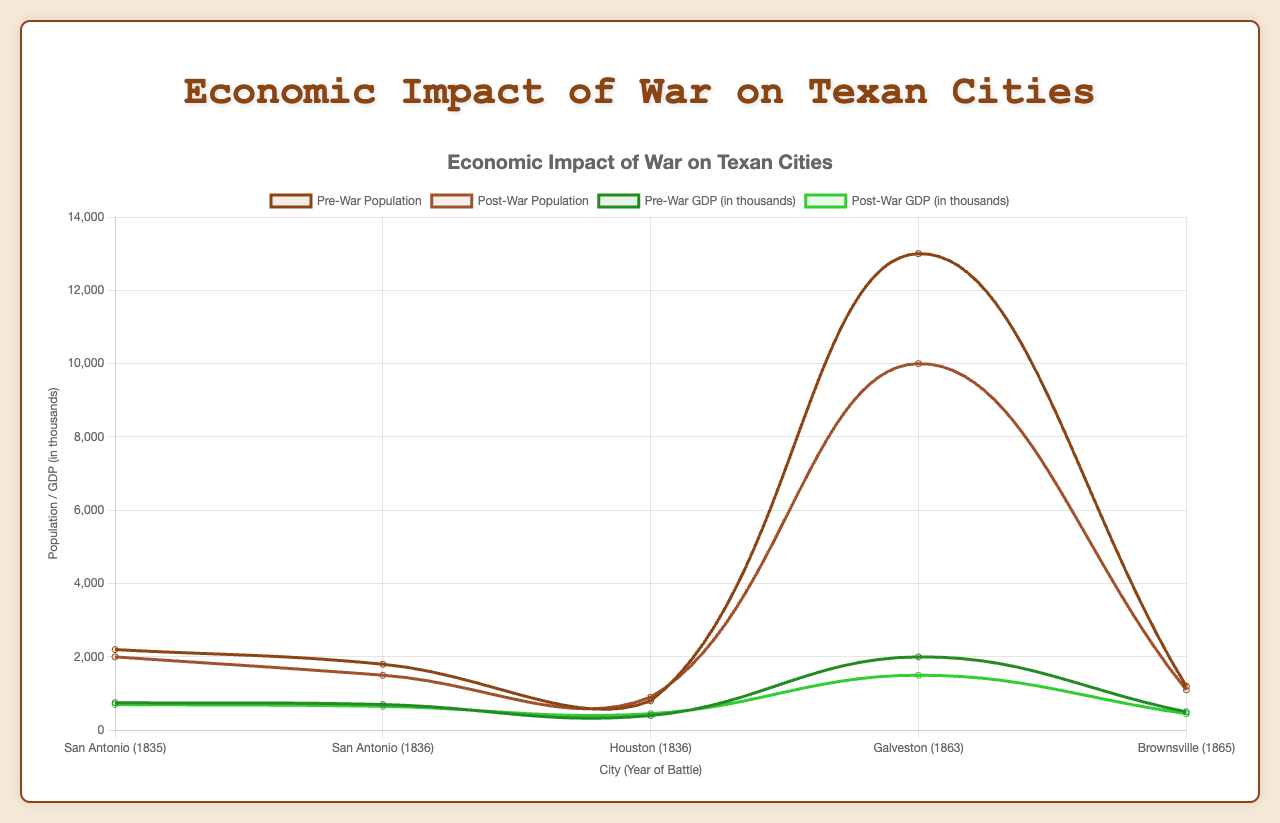What was the population of San Antonio before and after the Siege of Bexar? The figure shows the population data for San Antonio at different times. For the Siege of Bexar, San Antonio's population was 2200 before and 2000 after the battle.
Answer: 2200 before, 2000 after Which city experienced the greatest drop in GDP following their respective battle? To determine this, look for the largest difference between pre-war and post-war GDP for each city. Galveston dropped from 2000 (in thousands) pre-war to 1500 (in thousands) post-war, a decrease of 500 (in thousands).
Answer: Galveston Compare the unemployment rates of Houston before and after the Battle of San Jacinto. Referring to the chart, Houston's unemployment rate was 10.0% before the Battle of San Jacinto and 9.0% after the battle.
Answer: 10.0% before, 9.0% after How did the median income in Brownsville change due to the Battle of Palmito Ranch? The median income data for Brownsville show a pre-war median income of 400 and a post-war median income of 380, thus a decrease of 20.
Answer: Decreased by 20 Which color represents the post-war population data in the chart? Looking at the visual attributes of the datasets, the color that represents the post-war population is more reddish-brown compared to the pre-war population.
Answer: Reddish-brown Which battle had the highest pre-war unemployment rate? From the chart, the Siege of Bexar in San Antonio had the highest pre-war unemployment rate of 12.5%.
Answer: Siege of Bexar, 12.5% Calculate the total pre-war GDP (in thousands) for all cities combined. Summing up the pre-war GDP values for all cities we have 750 + 700 + 400 + 2000 + 500 = 4350 (in thousands).
Answer: 4350 (in thousands) What is the visual trend in the population change for San Antonio when comparing the Siege of Bexar and the Battle of the Alamo? Observing San Antonio for both battles, there's a visual step-down in population from 2200 to 2000 after Siege of Bexar, and further from 1800 to 1500 after Battle of the Alamo, indicating a consistent decline.
Answer: Consistent decline Compare the median income of Galveston before and after the Bombardment of Galveston. The figure shows that Galveston's median income before the bombardment was 800, and it dropped to 700 after the battle.
Answer: 800 before, 700 after 